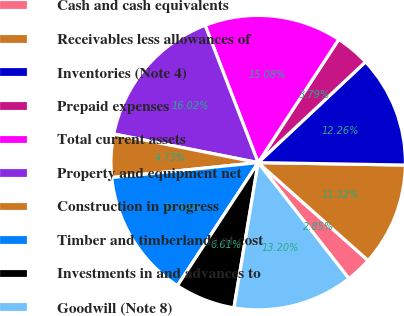Convert chart. <chart><loc_0><loc_0><loc_500><loc_500><pie_chart><fcel>Cash and cash equivalents<fcel>Receivables less allowances of<fcel>Inventories (Note 4)<fcel>Prepaid expenses<fcel>Total current assets<fcel>Property and equipment net<fcel>Construction in progress<fcel>Timber and timberlands at cost<fcel>Investments in and advances to<fcel>Goodwill (Note 8)<nl><fcel>2.85%<fcel>11.32%<fcel>12.26%<fcel>3.79%<fcel>15.08%<fcel>16.02%<fcel>4.73%<fcel>14.14%<fcel>6.61%<fcel>13.2%<nl></chart> 